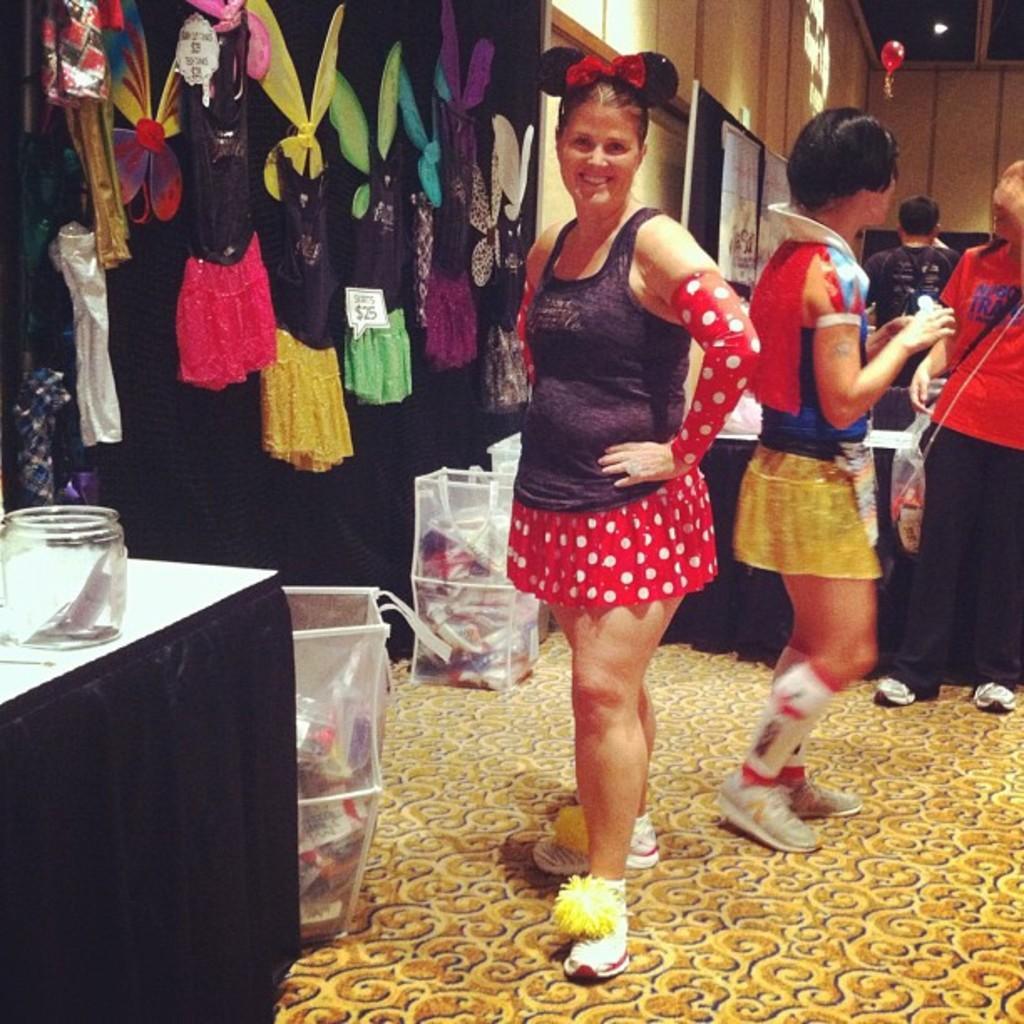Can you describe this image briefly? In the center of the image we can see a lady standing and smiling. On the left there are clothes hanging to the hanger. There is a table and we can see a bottle placed on the table. On the right there are people standing. At the bottom there are bags. In the background there is a wall. 